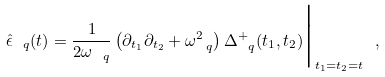Convert formula to latex. <formula><loc_0><loc_0><loc_500><loc_500>\hat { \epsilon } _ { \ q } ( t ) = \frac { 1 } { 2 \omega _ { \ q } } \left ( \partial _ { t _ { 1 } } \partial _ { t _ { 2 } } + \omega _ { \ q } ^ { 2 } \right ) \Delta ^ { + } _ { \ q } ( t _ { 1 } , t _ { 2 } ) \Big | _ { t _ { 1 } = t _ { 2 } = t } \ ,</formula> 